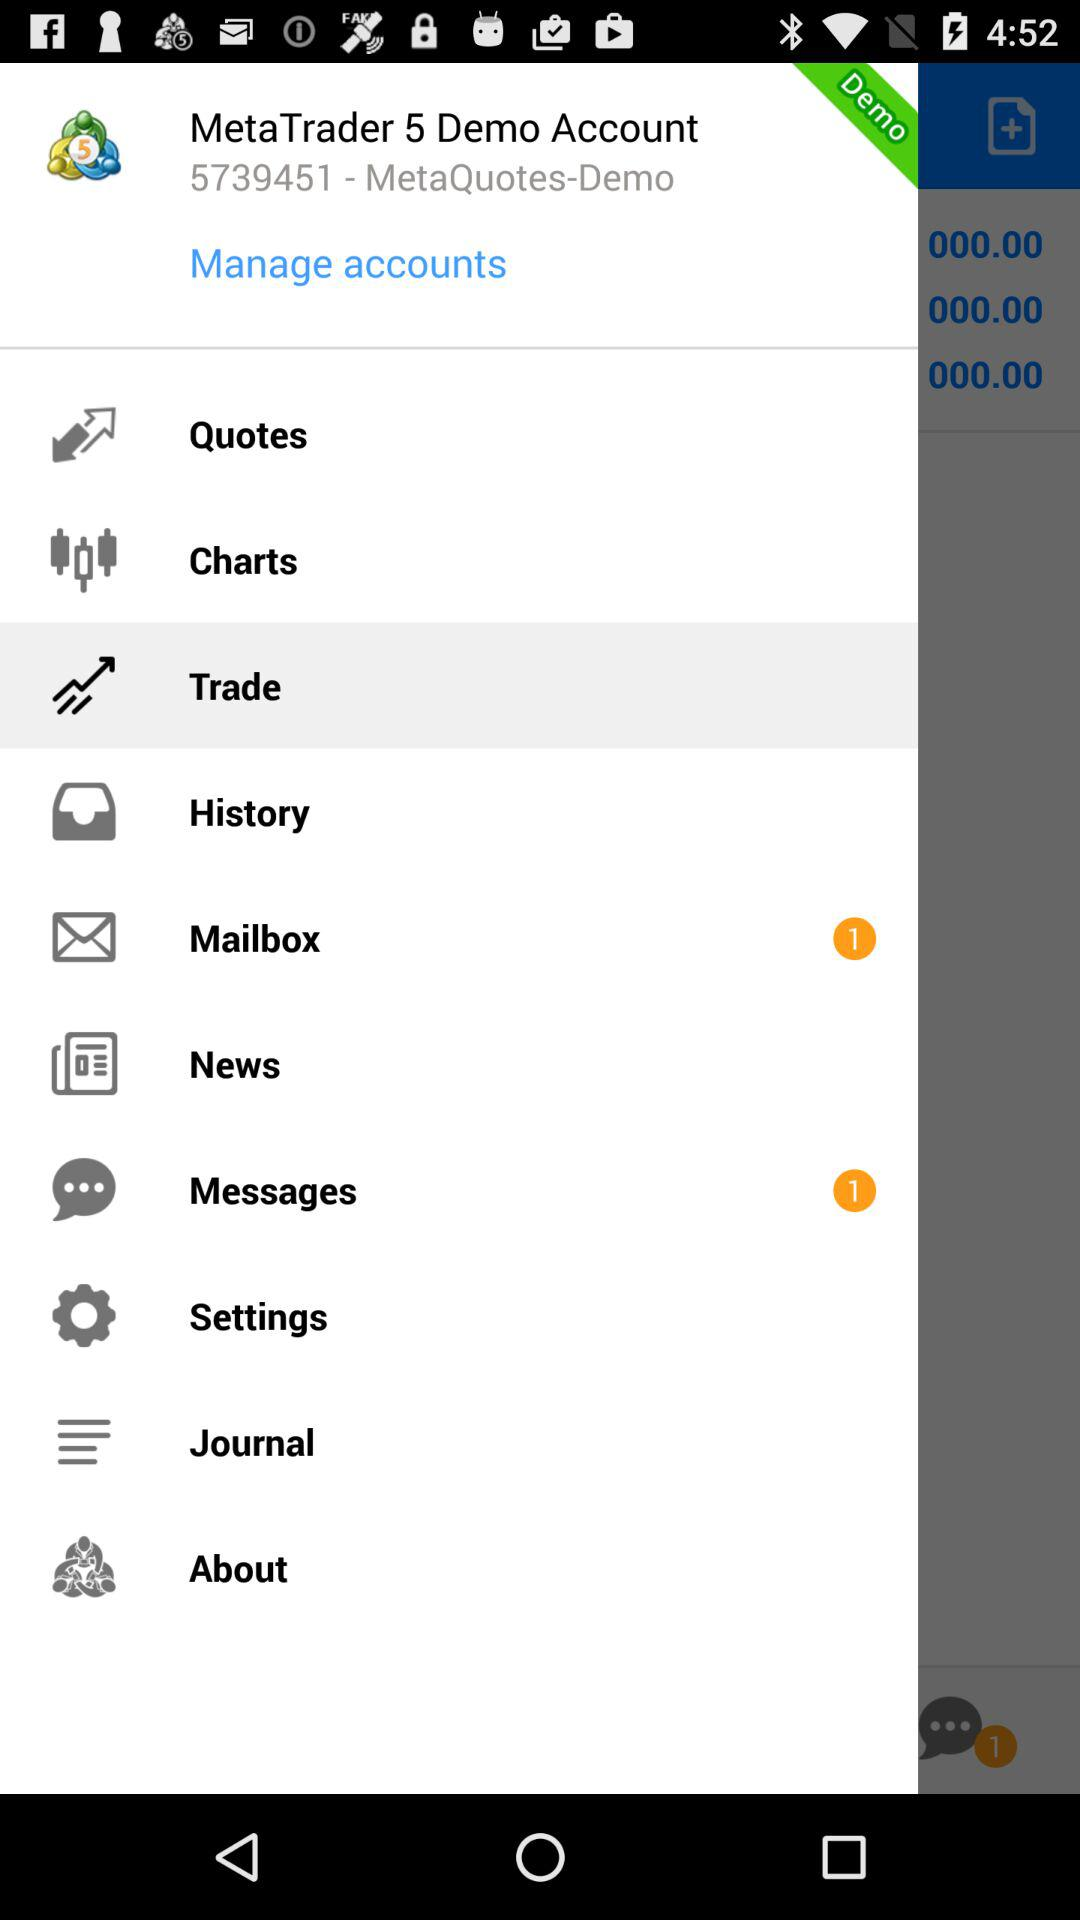Which option is highlighted? The highlighted option is "Trade". 